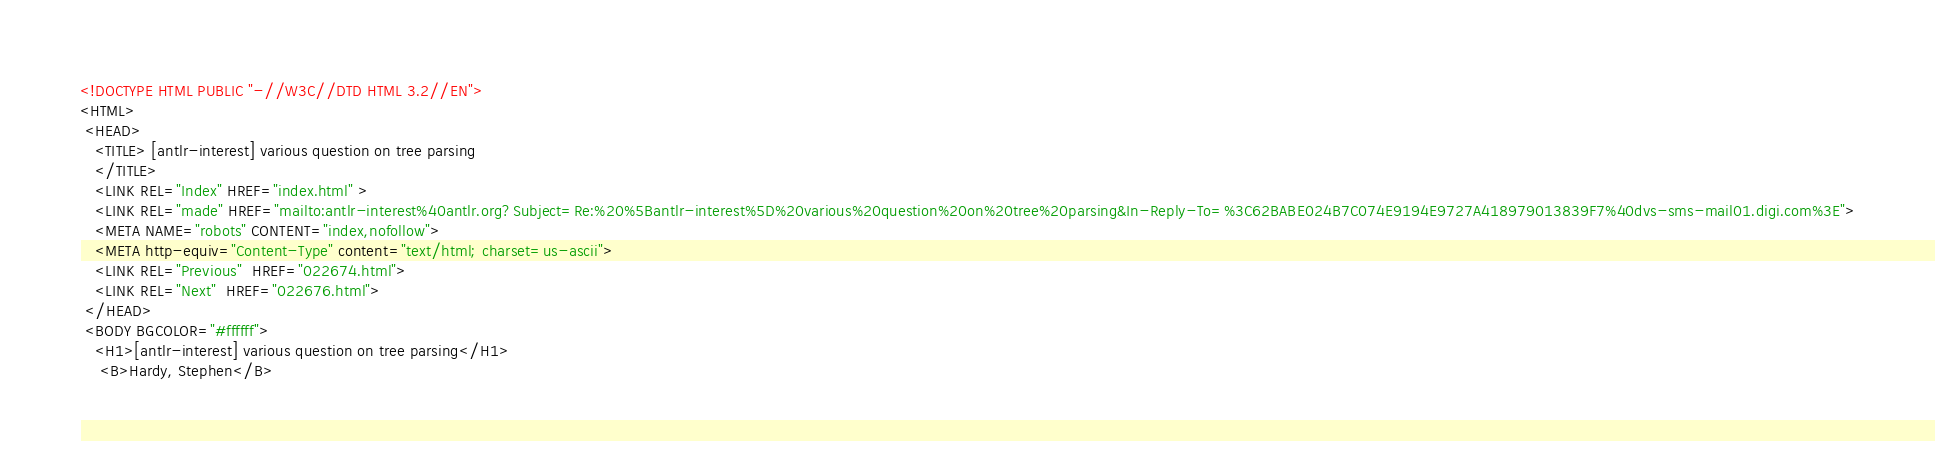<code> <loc_0><loc_0><loc_500><loc_500><_HTML_><!DOCTYPE HTML PUBLIC "-//W3C//DTD HTML 3.2//EN">
<HTML>
 <HEAD>
   <TITLE> [antlr-interest] various question on tree parsing
   </TITLE>
   <LINK REL="Index" HREF="index.html" >
   <LINK REL="made" HREF="mailto:antlr-interest%40antlr.org?Subject=Re:%20%5Bantlr-interest%5D%20various%20question%20on%20tree%20parsing&In-Reply-To=%3C62BABE024B7C074E9194E9727A418979013839F7%40dvs-sms-mail01.digi.com%3E">
   <META NAME="robots" CONTENT="index,nofollow">
   <META http-equiv="Content-Type" content="text/html; charset=us-ascii">
   <LINK REL="Previous"  HREF="022674.html">
   <LINK REL="Next"  HREF="022676.html">
 </HEAD>
 <BODY BGCOLOR="#ffffff">
   <H1>[antlr-interest] various question on tree parsing</H1>
    <B>Hardy, Stephen</B> </code> 